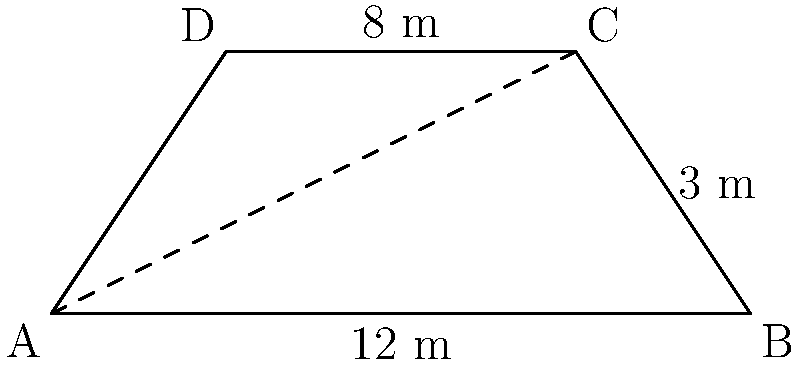Dans le cadre d'un litige de propriété, vous devez calculer l'aire d'une cour trapézoïdale. La cour a des côtés parallèles de 12 mètres et 8 mètres, avec une hauteur de 3 mètres. Quelle est l'aire de cette cour en mètres carrés? Pour calculer l'aire d'un trapèze, nous utilisons la formule :

$$ A = \frac{(b_1 + b_2)h}{2} $$

Où :
$A$ = aire
$b_1$ et $b_2$ = longueurs des côtés parallèles
$h$ = hauteur

Dans notre cas :
$b_1 = 12$ m
$b_2 = 8$ m
$h = 3$ m

Substituons ces valeurs dans la formule :

$$ A = \frac{(12 + 8) \times 3}{2} $$
$$ A = \frac{20 \times 3}{2} $$
$$ A = \frac{60}{2} $$
$$ A = 30 $$

Donc, l'aire de la cour trapézoïdale est de 30 mètres carrés.
Answer: 30 m² 